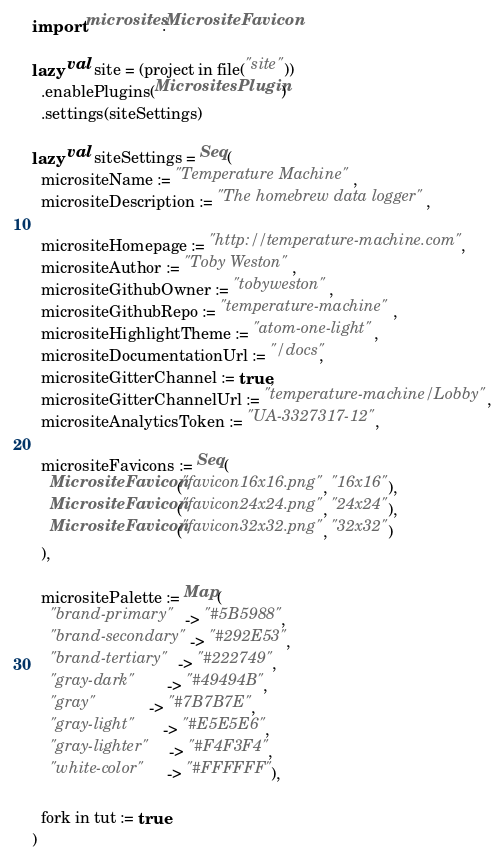Convert code to text. <code><loc_0><loc_0><loc_500><loc_500><_Scala_>import microsites.MicrositeFavicon

lazy val site = (project in file("site"))
  .enablePlugins(MicrositesPlugin)
  .settings(siteSettings)

lazy val siteSettings = Seq(
  micrositeName := "Temperature Machine",
  micrositeDescription := "The homebrew data logger",

  micrositeHomepage := "http://temperature-machine.com",
  micrositeAuthor := "Toby Weston",
  micrositeGithubOwner := "tobyweston",
  micrositeGithubRepo := "temperature-machine",
  micrositeHighlightTheme := "atom-one-light",
  micrositeDocumentationUrl := "/docs",
  micrositeGitterChannel := true,
  micrositeGitterChannelUrl := "temperature-machine/Lobby",
  micrositeAnalyticsToken := "UA-3327317-12",

  micrositeFavicons := Seq(
    MicrositeFavicon("favicon16x16.png", "16x16"),
    MicrositeFavicon("favicon24x24.png", "24x24"),
    MicrositeFavicon("favicon32x32.png", "32x32")
  ),

  micrositePalette := Map(
    "brand-primary"   -> "#5B5988",
    "brand-secondary" -> "#292E53",
    "brand-tertiary"  -> "#222749",
    "gray-dark"       -> "#49494B",
    "gray"            -> "#7B7B7E",
    "gray-light"      -> "#E5E5E6",
    "gray-lighter"    -> "#F4F3F4",
    "white-color"     -> "#FFFFFF"),

  fork in tut := true
)
</code> 